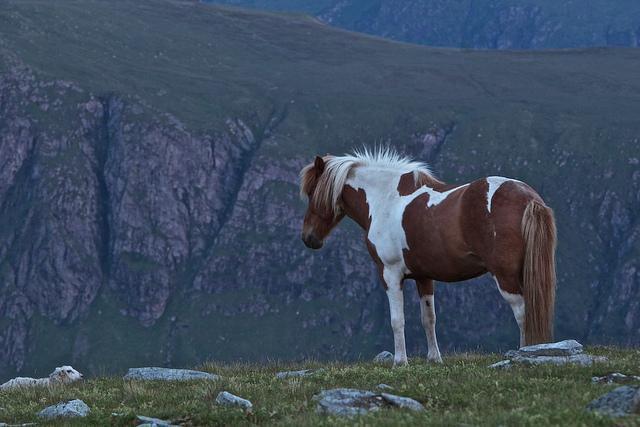How many women are pictured?
Give a very brief answer. 0. 